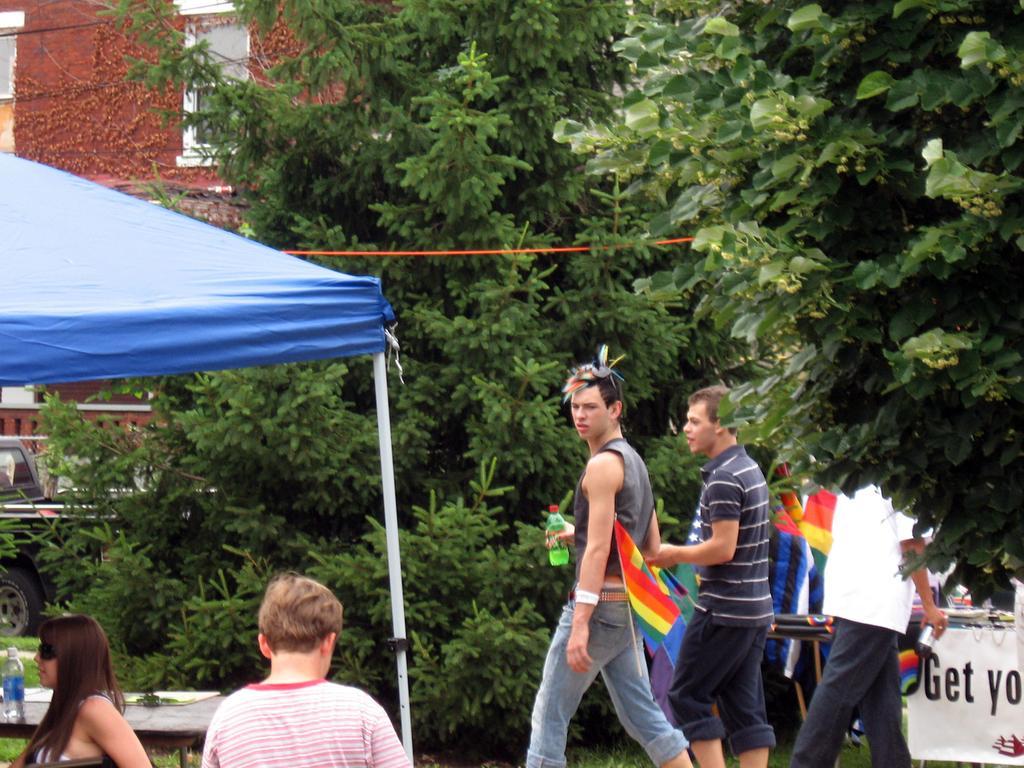In one or two sentences, can you explain what this image depicts? We can see bottle and objects on the table and this is tent and we can see banner and flags. In the background we can see trees and building. 